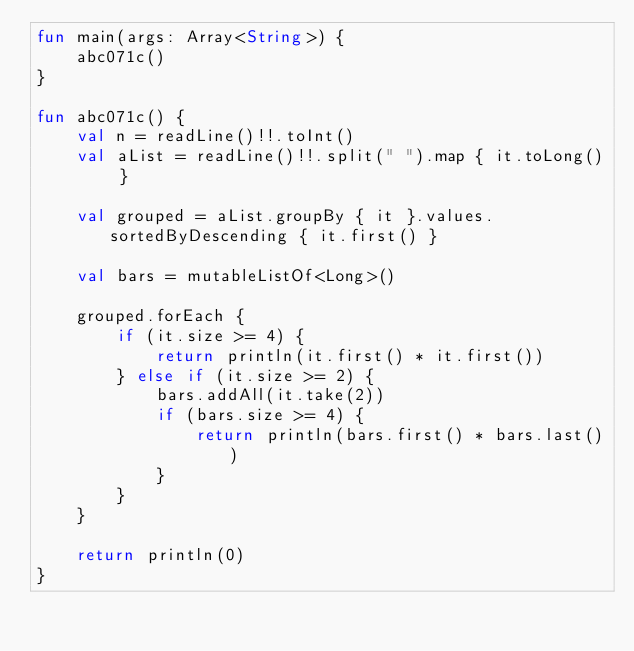<code> <loc_0><loc_0><loc_500><loc_500><_Kotlin_>fun main(args: Array<String>) {
    abc071c()
}

fun abc071c() {
    val n = readLine()!!.toInt()
    val aList = readLine()!!.split(" ").map { it.toLong() }

    val grouped = aList.groupBy { it }.values.sortedByDescending { it.first() }

    val bars = mutableListOf<Long>()

    grouped.forEach {
        if (it.size >= 4) {
            return println(it.first() * it.first())
        } else if (it.size >= 2) {
            bars.addAll(it.take(2))
            if (bars.size >= 4) {
                return println(bars.first() * bars.last())
            }
        }
    }

    return println(0)
}
</code> 